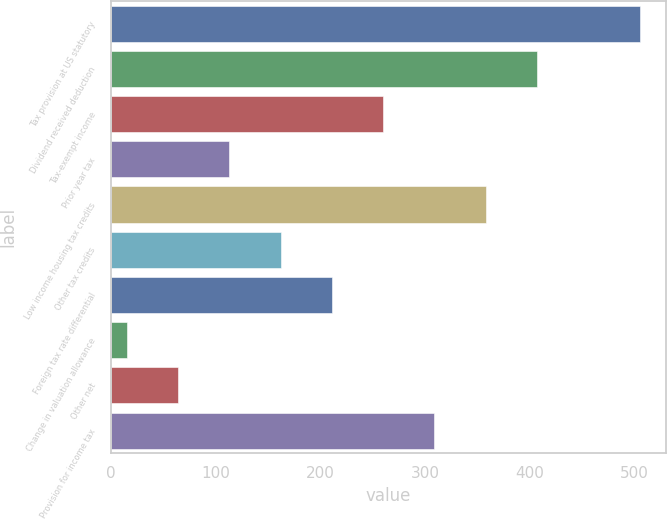<chart> <loc_0><loc_0><loc_500><loc_500><bar_chart><fcel>Tax provision at US statutory<fcel>Dividend received deduction<fcel>Tax-exempt income<fcel>Prior year tax<fcel>Low income housing tax credits<fcel>Other tax credits<fcel>Foreign tax rate differential<fcel>Change in valuation allowance<fcel>Other net<fcel>Provision for income tax<nl><fcel>505<fcel>407<fcel>260<fcel>113<fcel>358<fcel>162<fcel>211<fcel>15<fcel>64<fcel>309<nl></chart> 